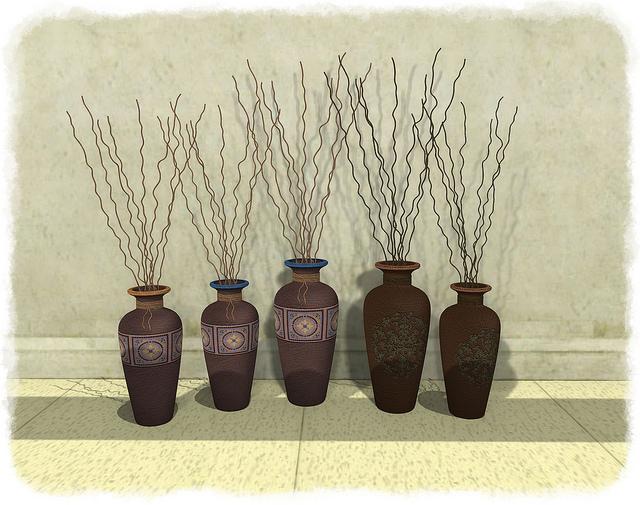How many vases are up against the wall?
Give a very brief answer. 5. How many different vase designs are there?
Give a very brief answer. 2. How many vases are there?
Give a very brief answer. 5. How many potted plants can be seen?
Give a very brief answer. 2. 